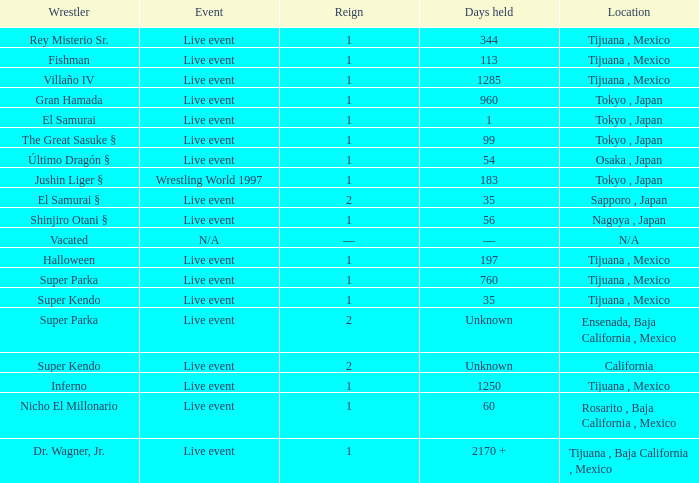Where did the wrestler, super parka, with the title with a reign of 2? Ensenada, Baja California , Mexico. 